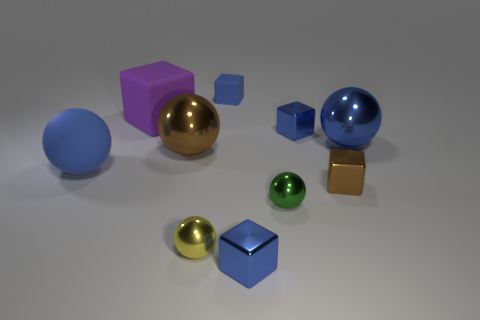How many brown shiny objects have the same size as the yellow sphere?
Your answer should be compact. 1. What size is the brown ball?
Offer a terse response. Large. There is a large brown shiny ball; what number of metallic blocks are behind it?
Make the answer very short. 1. There is a tiny brown object that is made of the same material as the large brown object; what shape is it?
Provide a succinct answer. Cube. Are there fewer small green balls right of the brown block than small matte cubes that are to the left of the big brown shiny object?
Ensure brevity in your answer.  No. Is the number of tiny gray rubber cylinders greater than the number of large purple rubber things?
Your answer should be compact. No. What is the material of the small yellow object?
Make the answer very short. Metal. The tiny metal block that is in front of the small yellow metal sphere is what color?
Offer a very short reply. Blue. Is the number of big brown metal spheres left of the big blue matte thing greater than the number of large objects left of the green metal object?
Make the answer very short. No. There is a green sphere in front of the big matte cube that is left of the big metallic object right of the yellow sphere; how big is it?
Provide a succinct answer. Small. 